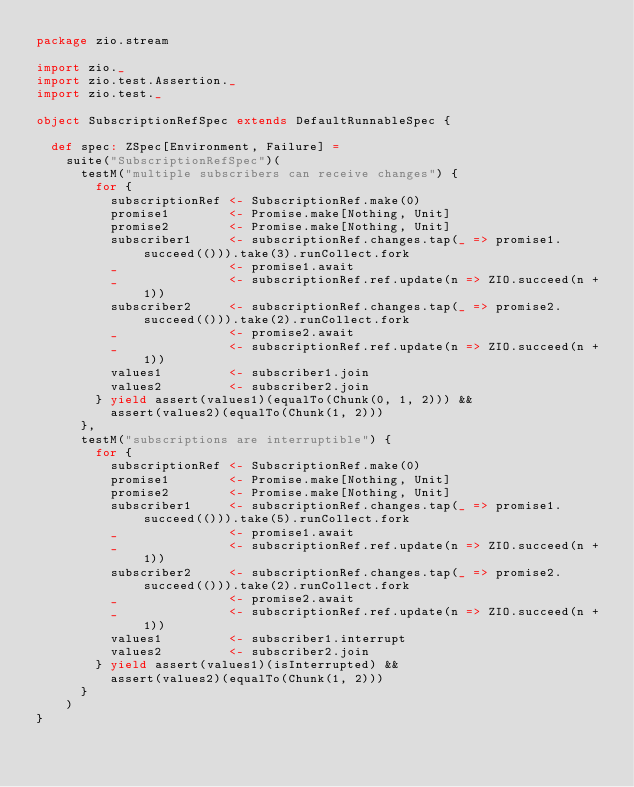<code> <loc_0><loc_0><loc_500><loc_500><_Scala_>package zio.stream

import zio._
import zio.test.Assertion._
import zio.test._

object SubscriptionRefSpec extends DefaultRunnableSpec {

  def spec: ZSpec[Environment, Failure] =
    suite("SubscriptionRefSpec")(
      testM("multiple subscribers can receive changes") {
        for {
          subscriptionRef <- SubscriptionRef.make(0)
          promise1        <- Promise.make[Nothing, Unit]
          promise2        <- Promise.make[Nothing, Unit]
          subscriber1     <- subscriptionRef.changes.tap(_ => promise1.succeed(())).take(3).runCollect.fork
          _               <- promise1.await
          _               <- subscriptionRef.ref.update(n => ZIO.succeed(n + 1))
          subscriber2     <- subscriptionRef.changes.tap(_ => promise2.succeed(())).take(2).runCollect.fork
          _               <- promise2.await
          _               <- subscriptionRef.ref.update(n => ZIO.succeed(n + 1))
          values1         <- subscriber1.join
          values2         <- subscriber2.join
        } yield assert(values1)(equalTo(Chunk(0, 1, 2))) &&
          assert(values2)(equalTo(Chunk(1, 2)))
      },
      testM("subscriptions are interruptible") {
        for {
          subscriptionRef <- SubscriptionRef.make(0)
          promise1        <- Promise.make[Nothing, Unit]
          promise2        <- Promise.make[Nothing, Unit]
          subscriber1     <- subscriptionRef.changes.tap(_ => promise1.succeed(())).take(5).runCollect.fork
          _               <- promise1.await
          _               <- subscriptionRef.ref.update(n => ZIO.succeed(n + 1))
          subscriber2     <- subscriptionRef.changes.tap(_ => promise2.succeed(())).take(2).runCollect.fork
          _               <- promise2.await
          _               <- subscriptionRef.ref.update(n => ZIO.succeed(n + 1))
          values1         <- subscriber1.interrupt
          values2         <- subscriber2.join
        } yield assert(values1)(isInterrupted) &&
          assert(values2)(equalTo(Chunk(1, 2)))
      }
    )
}
</code> 